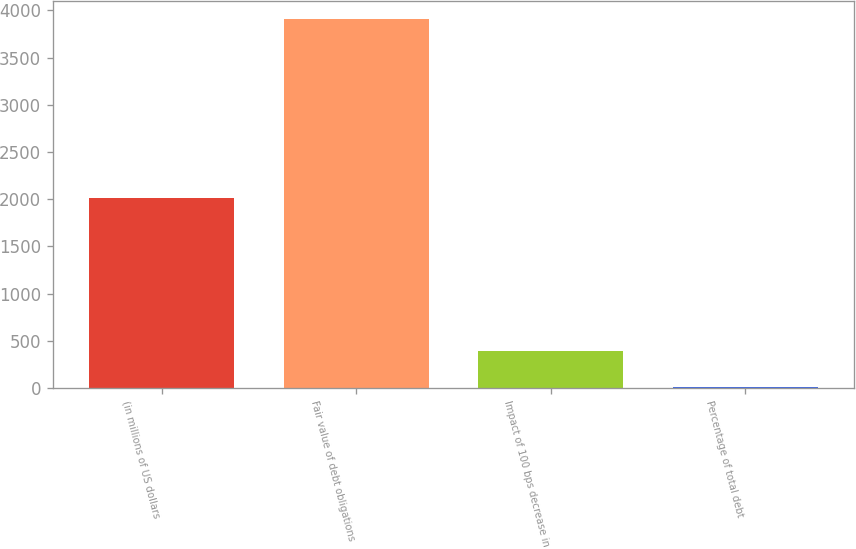Convert chart. <chart><loc_0><loc_0><loc_500><loc_500><bar_chart><fcel>(in millions of US dollars<fcel>Fair value of debt obligations<fcel>Impact of 100 bps decrease in<fcel>Percentage of total debt<nl><fcel>2009<fcel>3905<fcel>396.08<fcel>6.2<nl></chart> 